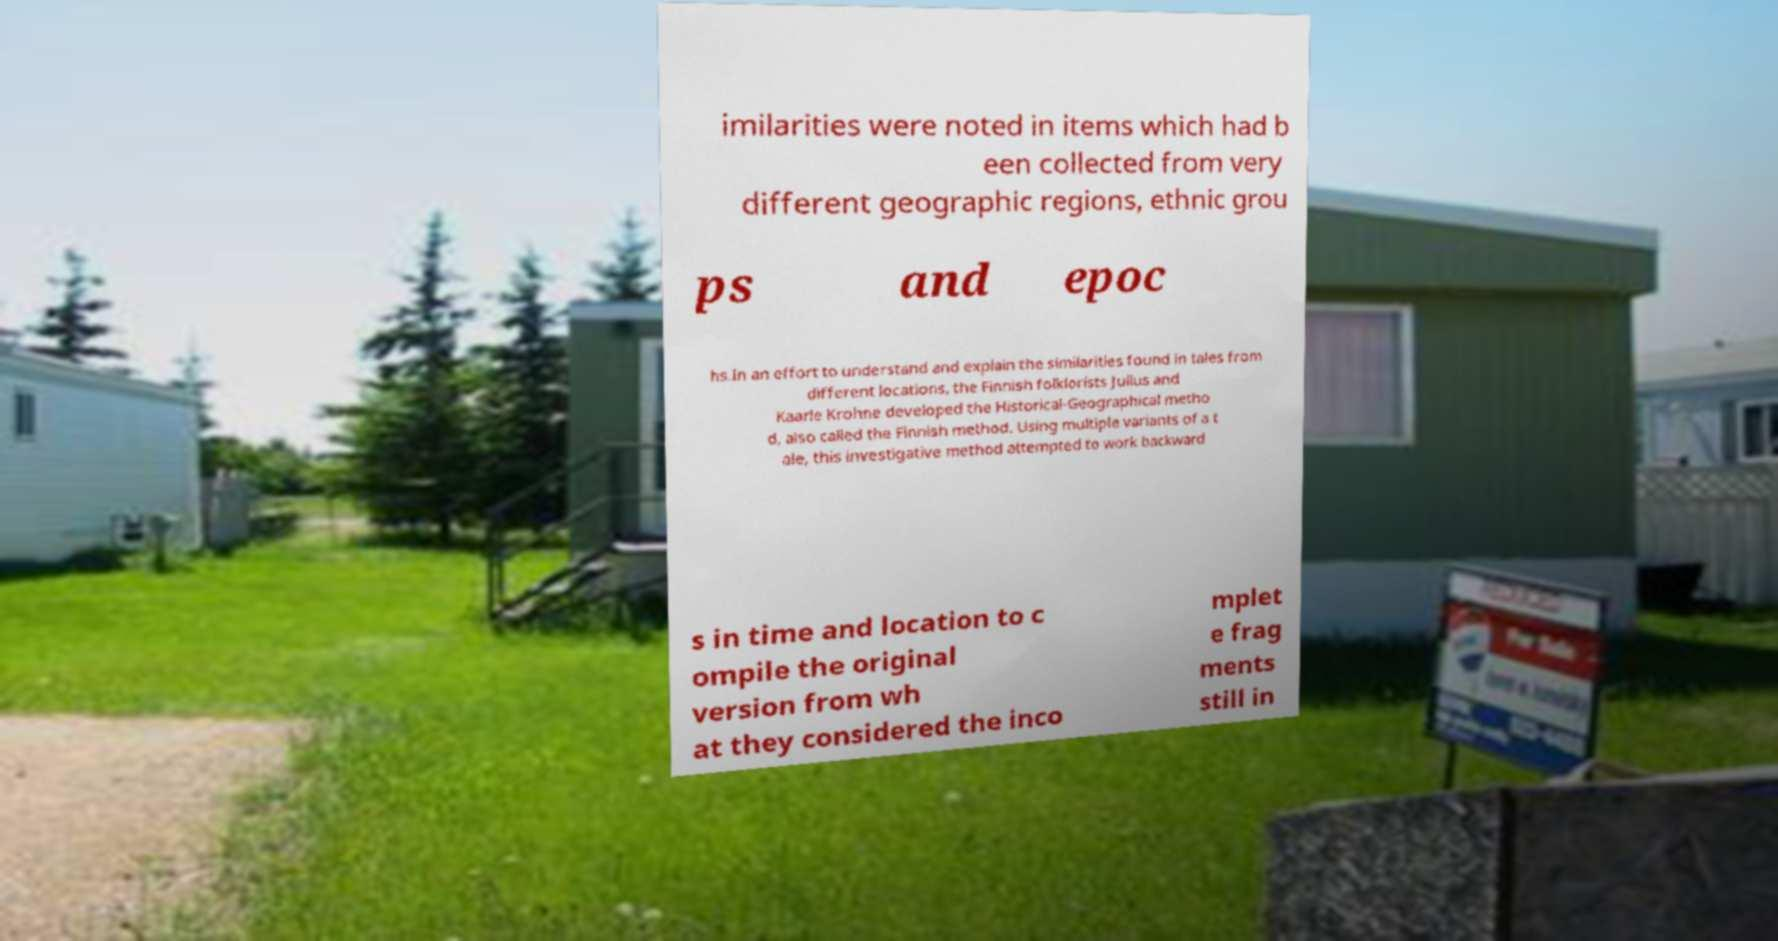Please identify and transcribe the text found in this image. imilarities were noted in items which had b een collected from very different geographic regions, ethnic grou ps and epoc hs.In an effort to understand and explain the similarities found in tales from different locations, the Finnish folklorists Julius and Kaarle Krohne developed the Historical-Geographical metho d, also called the Finnish method. Using multiple variants of a t ale, this investigative method attempted to work backward s in time and location to c ompile the original version from wh at they considered the inco mplet e frag ments still in 